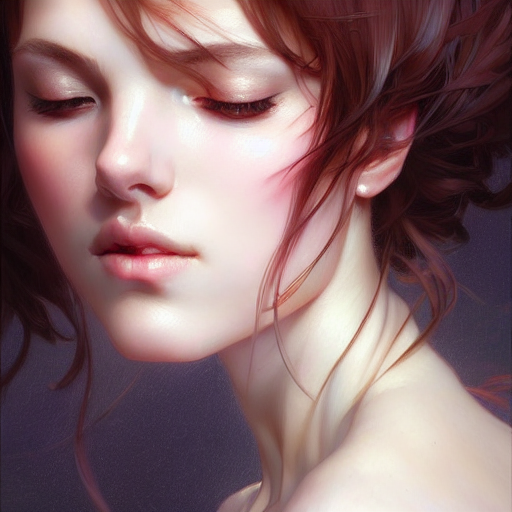Could you describe the artistic style used in this image? The image is rendered in a digital painting style, characterized by smooth brushwork, subtle gradations of color, and a realistic yet softened depiction of the subject's features which are hallmarks of modern digital portraiture. 